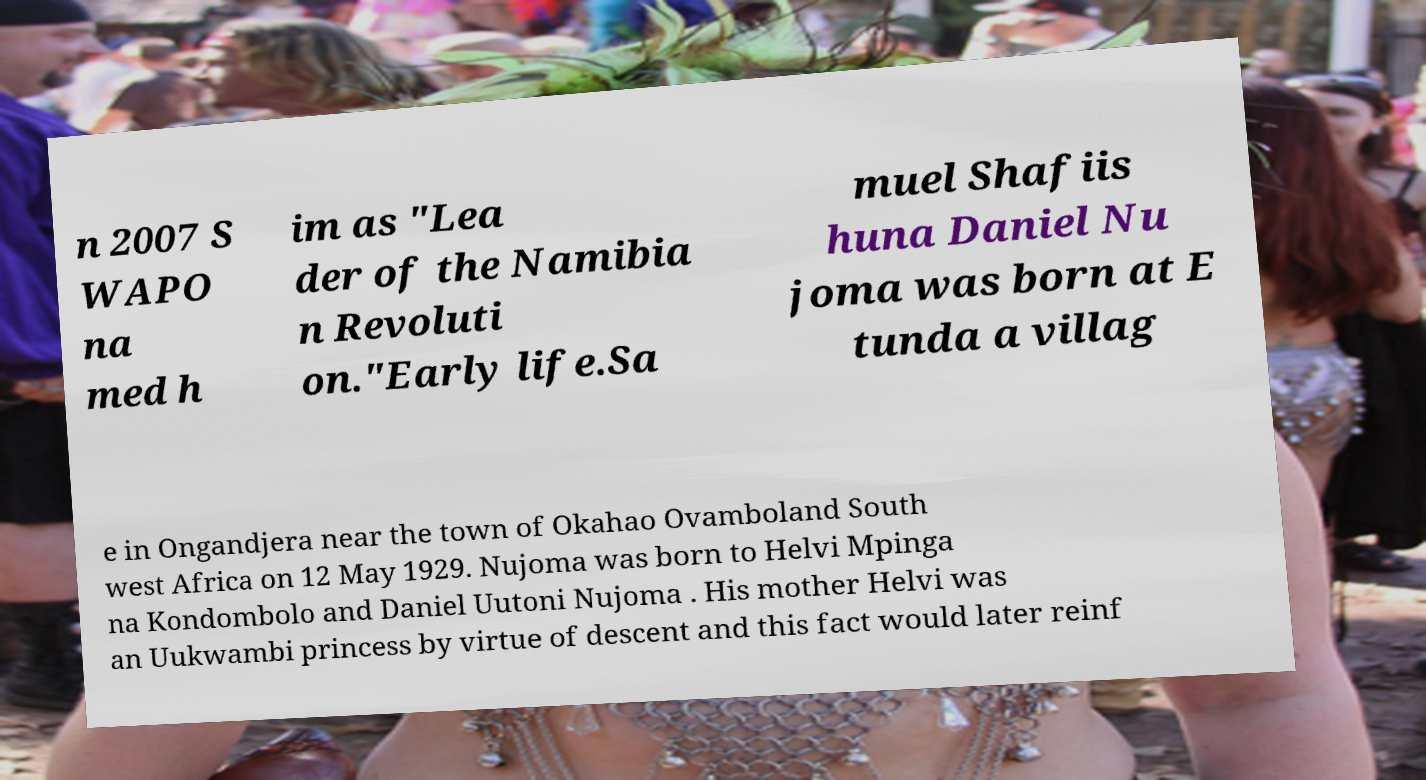Could you assist in decoding the text presented in this image and type it out clearly? n 2007 S WAPO na med h im as "Lea der of the Namibia n Revoluti on."Early life.Sa muel Shafiis huna Daniel Nu joma was born at E tunda a villag e in Ongandjera near the town of Okahao Ovamboland South west Africa on 12 May 1929. Nujoma was born to Helvi Mpinga na Kondombolo and Daniel Uutoni Nujoma . His mother Helvi was an Uukwambi princess by virtue of descent and this fact would later reinf 